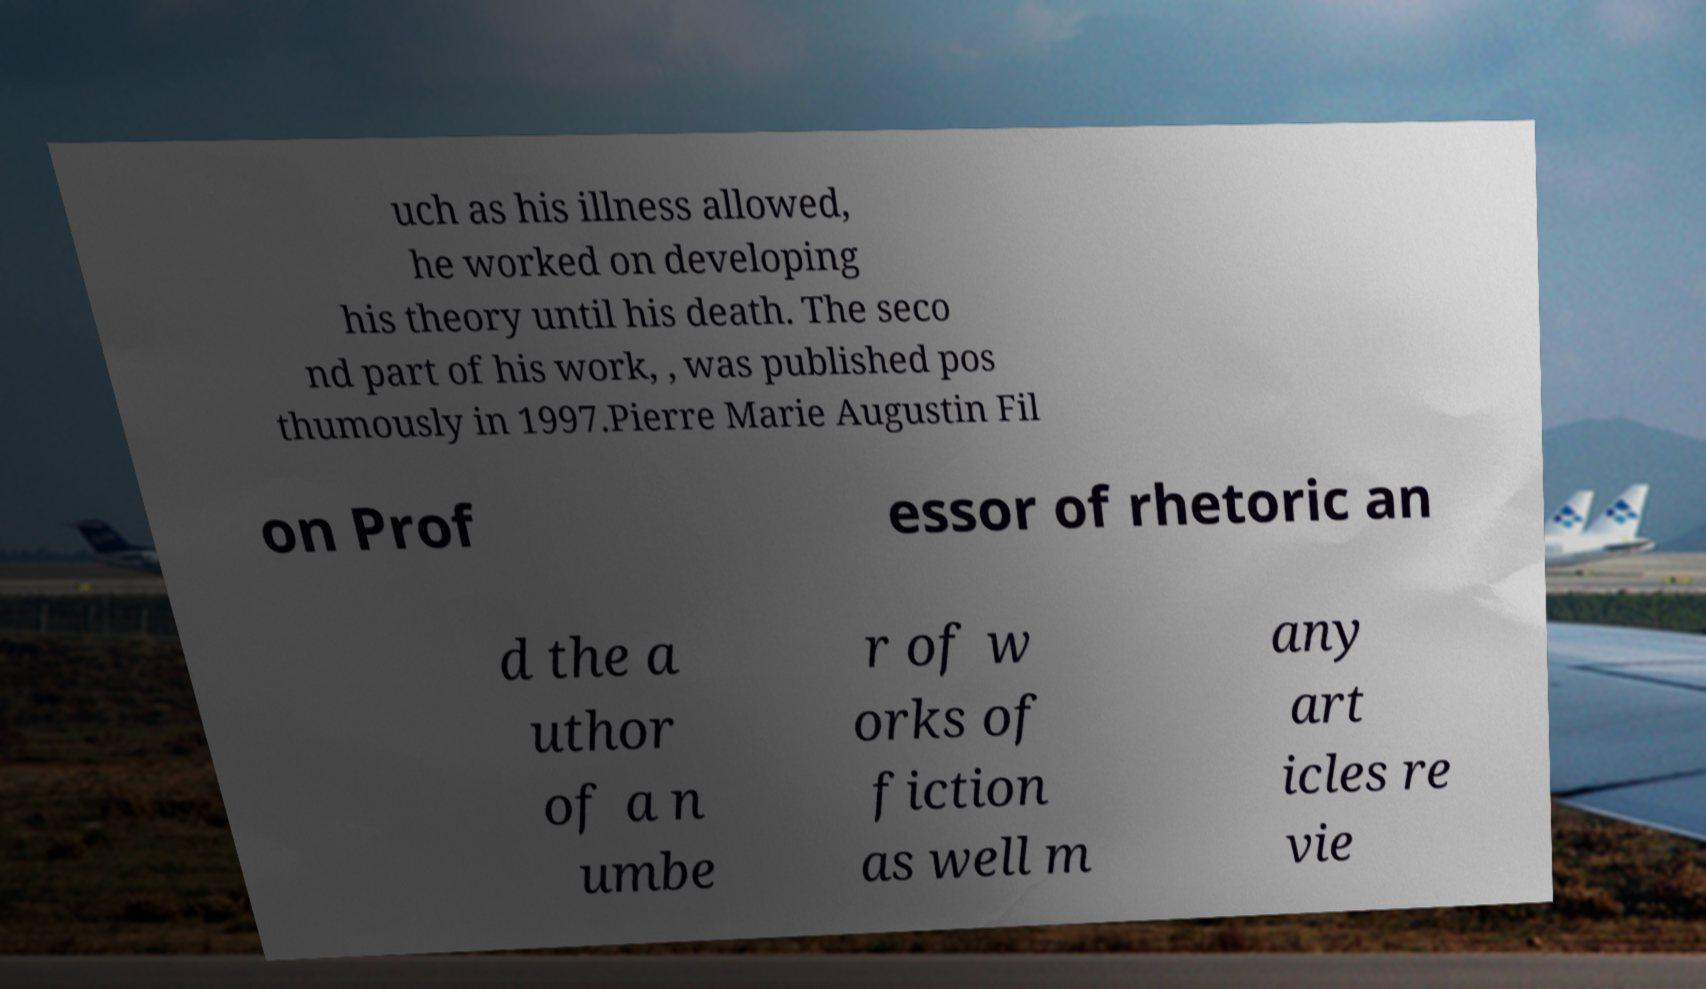Please identify and transcribe the text found in this image. uch as his illness allowed, he worked on developing his theory until his death. The seco nd part of his work, , was published pos thumously in 1997.Pierre Marie Augustin Fil on Prof essor of rhetoric an d the a uthor of a n umbe r of w orks of fiction as well m any art icles re vie 